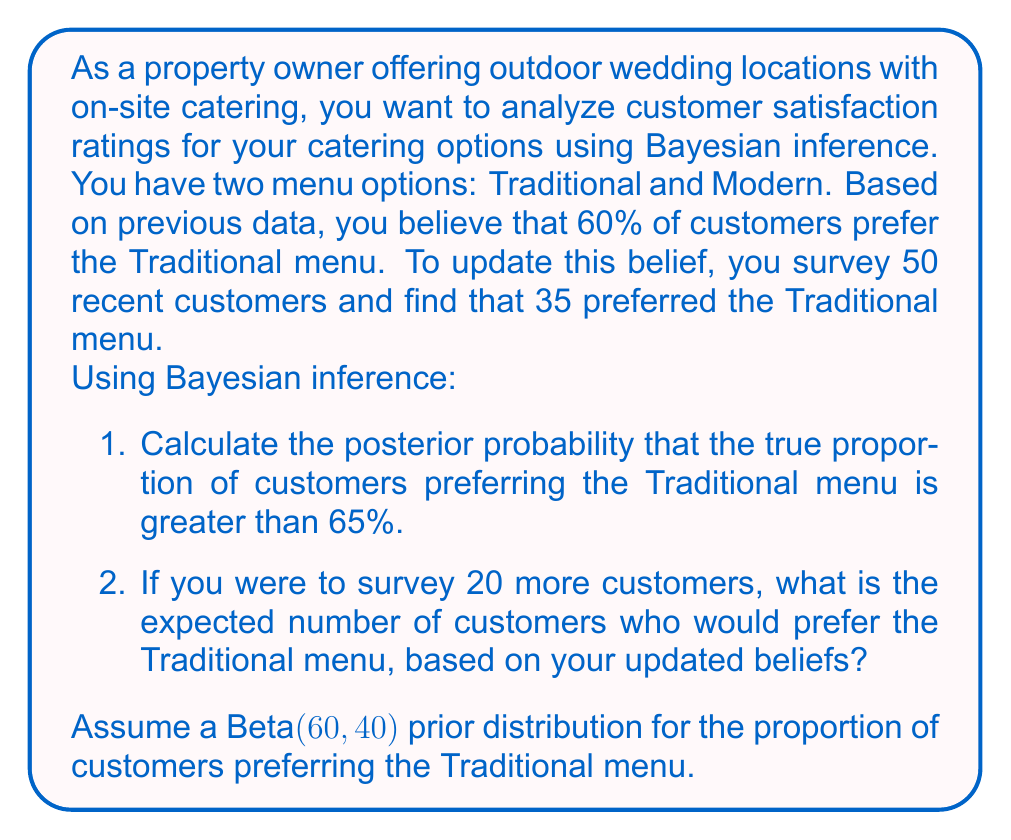Help me with this question. Let's approach this problem step-by-step using Bayesian inference:

1. First, we need to calculate the posterior distribution:

   Prior: Beta(60, 40)
   Data: 35 successes out of 50 trials
   Posterior: Beta(60 + 35, 40 + 15) = Beta(95, 55)

2. To calculate the probability that the true proportion is greater than 65%, we need to integrate the posterior distribution from 0.65 to 1:

   $$P(\theta > 0.65 | \text{data}) = 1 - \text{CDF}_{\text{Beta}(95,55)}(0.65)$$

   This can be calculated using statistical software or a Beta distribution calculator. The result is approximately 0.0183.

3. For the expected number of customers preferring the Traditional menu in a new survey of 20 customers, we use the expected value of the posterior distribution:

   $$E[\theta | \text{data}] = \frac{\alpha}{\alpha + \beta} = \frac{95}{95 + 55} = \frac{95}{150} \approx 0.6333$$

   Expected number = 20 * 0.6333 ≈ 12.67

Therefore, we expect about 13 out of 20 new customers to prefer the Traditional menu.
Answer: 1. $P(\theta > 0.65 | \text{data}) \approx 0.0183$
2. Expected number preferring Traditional menu: 13 out of 20 